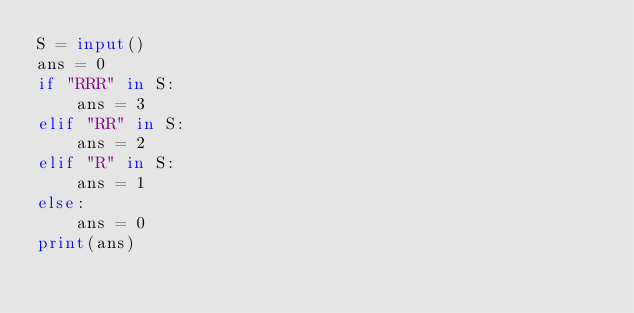<code> <loc_0><loc_0><loc_500><loc_500><_Python_>S = input()
ans = 0
if "RRR" in S:
    ans = 3
elif "RR" in S:
    ans = 2
elif "R" in S:
    ans = 1
else:
    ans = 0
print(ans)</code> 